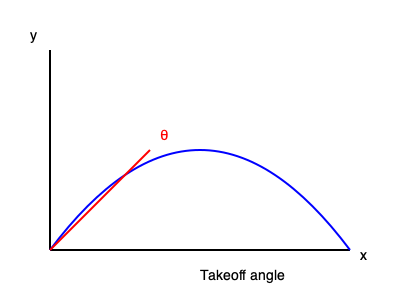Based on the diagram, what is the optimal takeoff angle for a long jump to achieve maximum horizontal distance, assuming negligible air resistance? To determine the optimal takeoff angle for a long jump, we need to consider the principles of projectile motion:

1. In projectile motion, the path of an object follows a parabolic trajectory, as shown in the blue curve in the diagram.

2. The horizontal distance traveled by a projectile is given by the equation:

   $$R = \frac{v^2 \sin(2\theta)}{g}$$

   Where $R$ is the range (horizontal distance), $v$ is the initial velocity, $\theta$ is the takeoff angle, and $g$ is the acceleration due to gravity.

3. To maximize the horizontal distance, we need to maximize $\sin(2\theta)$.

4. The maximum value of $\sin(2\theta)$ occurs when $2\theta = 90°$ or $\theta = 45°$.

5. Therefore, mathematically, the optimal takeoff angle for maximum horizontal distance is 45°.

6. However, in practical long jump situations, the optimal angle is slightly lower (around 20-25°) due to factors such as:
   - The jumper's center of mass is already elevated at takeoff.
   - The importance of maintaining horizontal velocity.
   - The need to prepare for landing.

7. For the purposes of this theoretical question, without considering these practical factors, we focus on the mathematical optimum.
Answer: 45° 